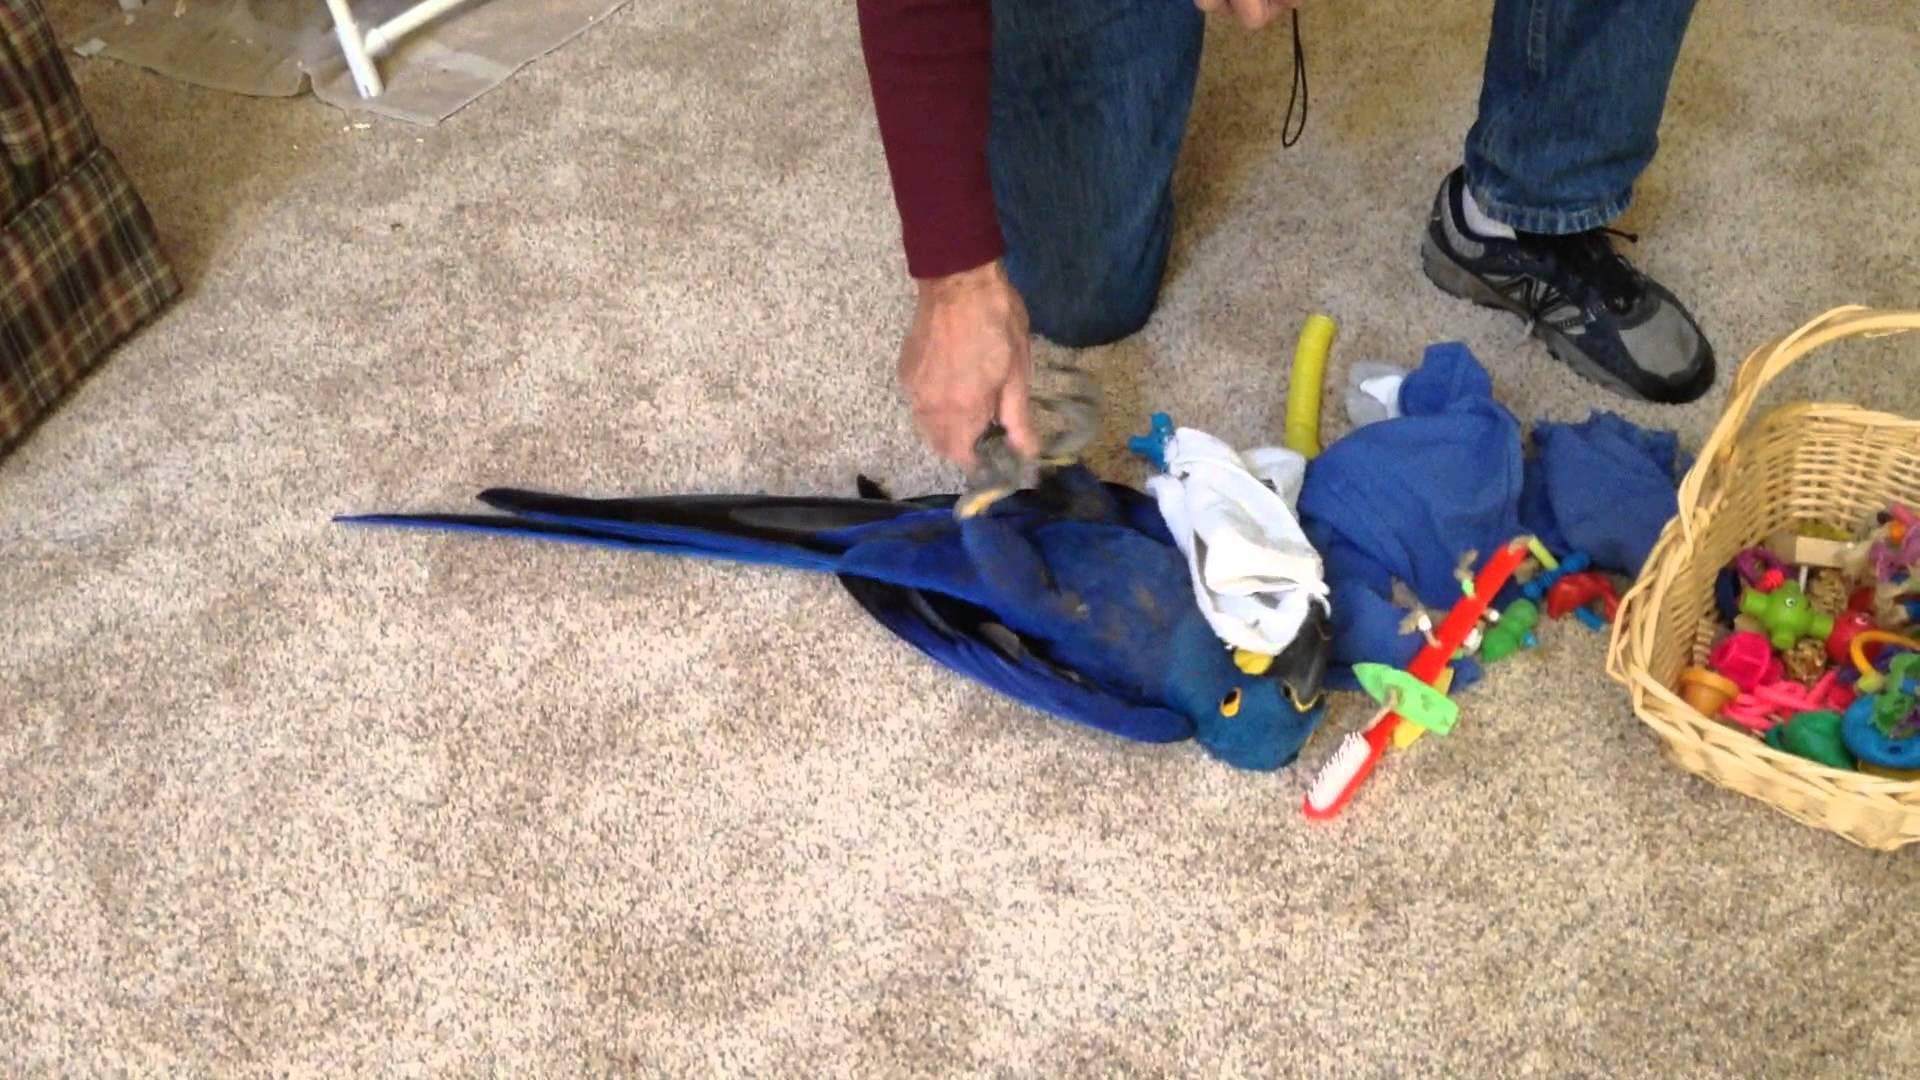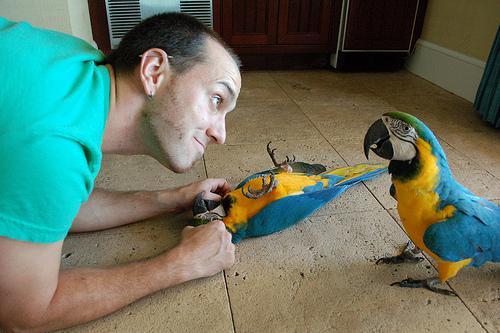The first image is the image on the left, the second image is the image on the right. Assess this claim about the two images: "There is a human petting a bird in at least one of the images.". Correct or not? Answer yes or no. Yes. The first image is the image on the left, the second image is the image on the right. For the images shown, is this caption "At least one image shows a person touching a parrot that is on its back." true? Answer yes or no. Yes. 